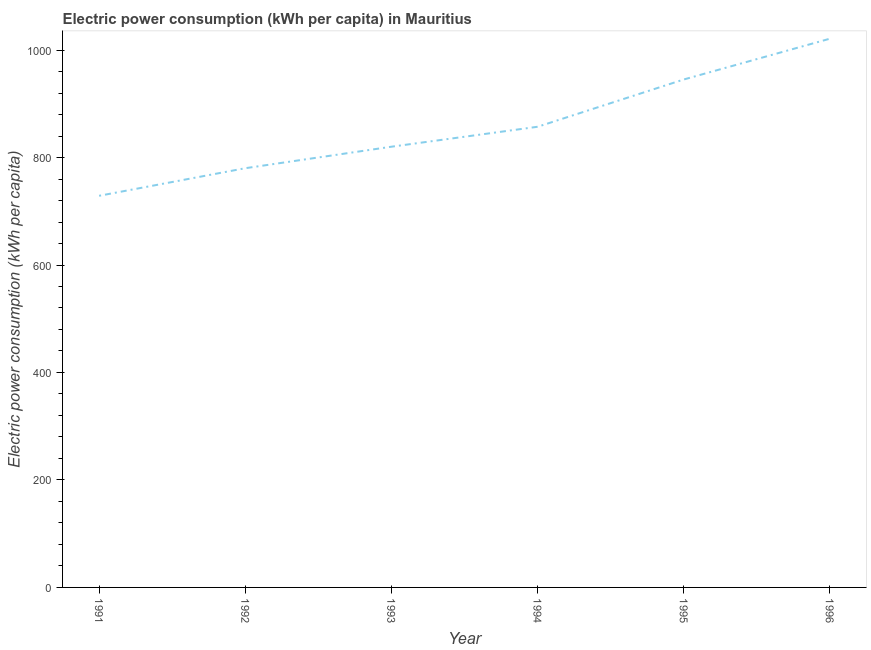What is the electric power consumption in 1996?
Provide a succinct answer. 1021.17. Across all years, what is the maximum electric power consumption?
Keep it short and to the point. 1021.17. Across all years, what is the minimum electric power consumption?
Provide a short and direct response. 728.79. In which year was the electric power consumption maximum?
Make the answer very short. 1996. In which year was the electric power consumption minimum?
Ensure brevity in your answer.  1991. What is the sum of the electric power consumption?
Give a very brief answer. 5152.73. What is the difference between the electric power consumption in 1994 and 1996?
Your answer should be compact. -163.91. What is the average electric power consumption per year?
Provide a short and direct response. 858.79. What is the median electric power consumption?
Make the answer very short. 838.7. In how many years, is the electric power consumption greater than 480 kWh per capita?
Keep it short and to the point. 6. Do a majority of the years between 1993 and 1992 (inclusive) have electric power consumption greater than 280 kWh per capita?
Make the answer very short. No. What is the ratio of the electric power consumption in 1991 to that in 1995?
Offer a very short reply. 0.77. Is the difference between the electric power consumption in 1992 and 1993 greater than the difference between any two years?
Make the answer very short. No. What is the difference between the highest and the second highest electric power consumption?
Provide a short and direct response. 75.92. Is the sum of the electric power consumption in 1993 and 1995 greater than the maximum electric power consumption across all years?
Provide a short and direct response. Yes. What is the difference between the highest and the lowest electric power consumption?
Your answer should be very brief. 292.38. How many lines are there?
Offer a very short reply. 1. How many years are there in the graph?
Your answer should be compact. 6. What is the difference between two consecutive major ticks on the Y-axis?
Give a very brief answer. 200. Does the graph contain any zero values?
Your response must be concise. No. Does the graph contain grids?
Provide a succinct answer. No. What is the title of the graph?
Ensure brevity in your answer.  Electric power consumption (kWh per capita) in Mauritius. What is the label or title of the X-axis?
Offer a very short reply. Year. What is the label or title of the Y-axis?
Your answer should be very brief. Electric power consumption (kWh per capita). What is the Electric power consumption (kWh per capita) of 1991?
Offer a terse response. 728.79. What is the Electric power consumption (kWh per capita) of 1992?
Give a very brief answer. 780.13. What is the Electric power consumption (kWh per capita) of 1993?
Your response must be concise. 820.14. What is the Electric power consumption (kWh per capita) of 1994?
Provide a succinct answer. 857.26. What is the Electric power consumption (kWh per capita) in 1995?
Provide a succinct answer. 945.25. What is the Electric power consumption (kWh per capita) in 1996?
Provide a succinct answer. 1021.17. What is the difference between the Electric power consumption (kWh per capita) in 1991 and 1992?
Keep it short and to the point. -51.33. What is the difference between the Electric power consumption (kWh per capita) in 1991 and 1993?
Give a very brief answer. -91.35. What is the difference between the Electric power consumption (kWh per capita) in 1991 and 1994?
Make the answer very short. -128.47. What is the difference between the Electric power consumption (kWh per capita) in 1991 and 1995?
Offer a terse response. -216.46. What is the difference between the Electric power consumption (kWh per capita) in 1991 and 1996?
Offer a terse response. -292.38. What is the difference between the Electric power consumption (kWh per capita) in 1992 and 1993?
Ensure brevity in your answer.  -40.01. What is the difference between the Electric power consumption (kWh per capita) in 1992 and 1994?
Your answer should be very brief. -77.14. What is the difference between the Electric power consumption (kWh per capita) in 1992 and 1995?
Make the answer very short. -165.12. What is the difference between the Electric power consumption (kWh per capita) in 1992 and 1996?
Give a very brief answer. -241.04. What is the difference between the Electric power consumption (kWh per capita) in 1993 and 1994?
Your answer should be compact. -37.12. What is the difference between the Electric power consumption (kWh per capita) in 1993 and 1995?
Provide a short and direct response. -125.11. What is the difference between the Electric power consumption (kWh per capita) in 1993 and 1996?
Your response must be concise. -201.03. What is the difference between the Electric power consumption (kWh per capita) in 1994 and 1995?
Your answer should be compact. -87.99. What is the difference between the Electric power consumption (kWh per capita) in 1994 and 1996?
Your answer should be compact. -163.91. What is the difference between the Electric power consumption (kWh per capita) in 1995 and 1996?
Offer a terse response. -75.92. What is the ratio of the Electric power consumption (kWh per capita) in 1991 to that in 1992?
Provide a succinct answer. 0.93. What is the ratio of the Electric power consumption (kWh per capita) in 1991 to that in 1993?
Give a very brief answer. 0.89. What is the ratio of the Electric power consumption (kWh per capita) in 1991 to that in 1995?
Provide a short and direct response. 0.77. What is the ratio of the Electric power consumption (kWh per capita) in 1991 to that in 1996?
Keep it short and to the point. 0.71. What is the ratio of the Electric power consumption (kWh per capita) in 1992 to that in 1993?
Keep it short and to the point. 0.95. What is the ratio of the Electric power consumption (kWh per capita) in 1992 to that in 1994?
Ensure brevity in your answer.  0.91. What is the ratio of the Electric power consumption (kWh per capita) in 1992 to that in 1995?
Provide a short and direct response. 0.82. What is the ratio of the Electric power consumption (kWh per capita) in 1992 to that in 1996?
Make the answer very short. 0.76. What is the ratio of the Electric power consumption (kWh per capita) in 1993 to that in 1994?
Give a very brief answer. 0.96. What is the ratio of the Electric power consumption (kWh per capita) in 1993 to that in 1995?
Make the answer very short. 0.87. What is the ratio of the Electric power consumption (kWh per capita) in 1993 to that in 1996?
Your response must be concise. 0.8. What is the ratio of the Electric power consumption (kWh per capita) in 1994 to that in 1995?
Provide a succinct answer. 0.91. What is the ratio of the Electric power consumption (kWh per capita) in 1994 to that in 1996?
Provide a short and direct response. 0.84. What is the ratio of the Electric power consumption (kWh per capita) in 1995 to that in 1996?
Your answer should be very brief. 0.93. 